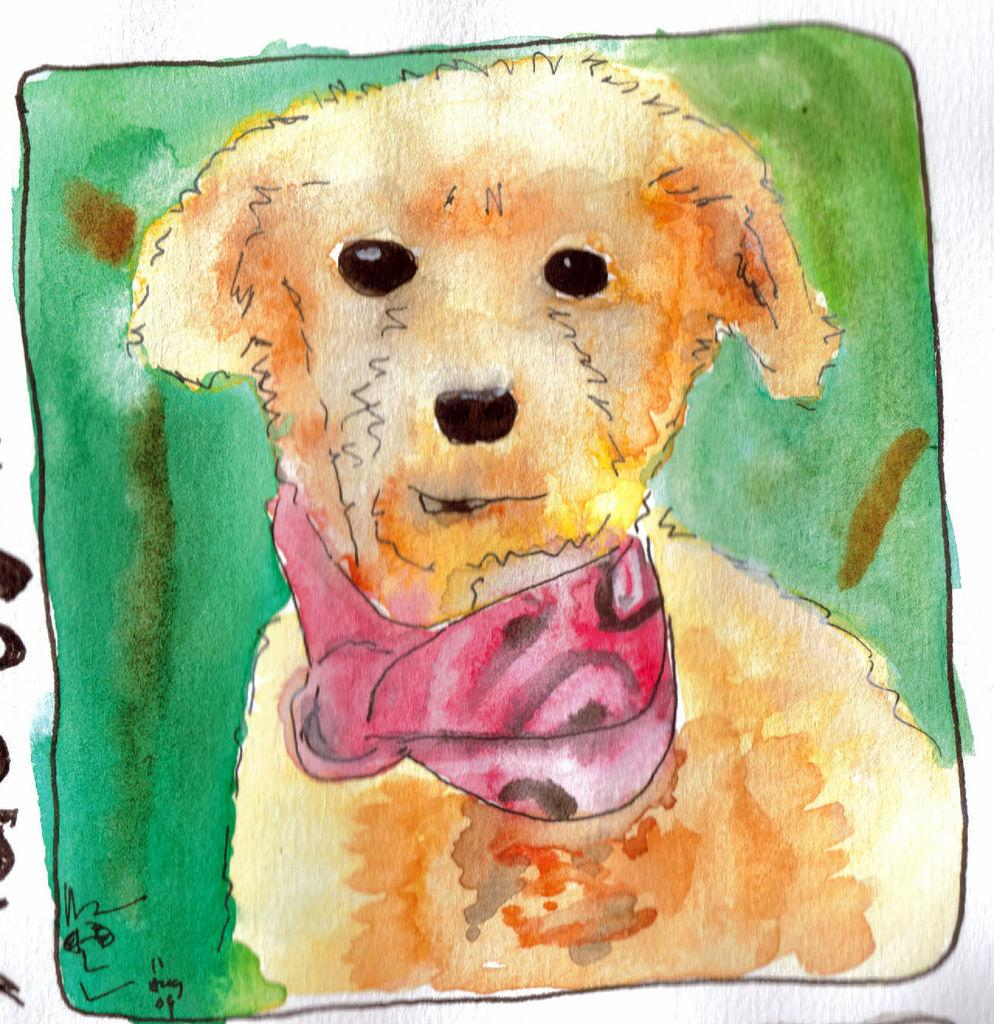What is depicted in the painting in the image? There is a painting of a dog in the image. What type of popcorn is being served on the channel in the image? There is no popcorn or channel present in the image; it features a painting of a dog. 